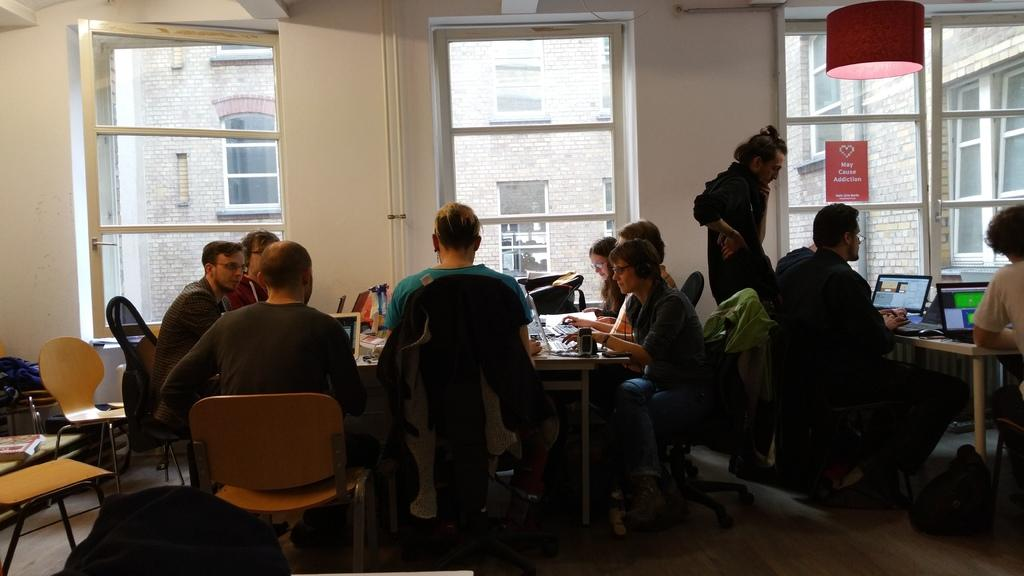What type of structure can be seen in the image? There is a building in the image. What is attached to the building? There is a wall and a window in the image. What can be found near the window? There is a pipe in the image. What are the people in the image doing? There are people sitting on chairs in the image. What is on the table in the image? There are laptops and papers on the table. Where is the bucket located in the image? There is no bucket present in the image. What type of lock is securing the window in the image? There is no lock visible in the image, as the window is not shown to be secured. 